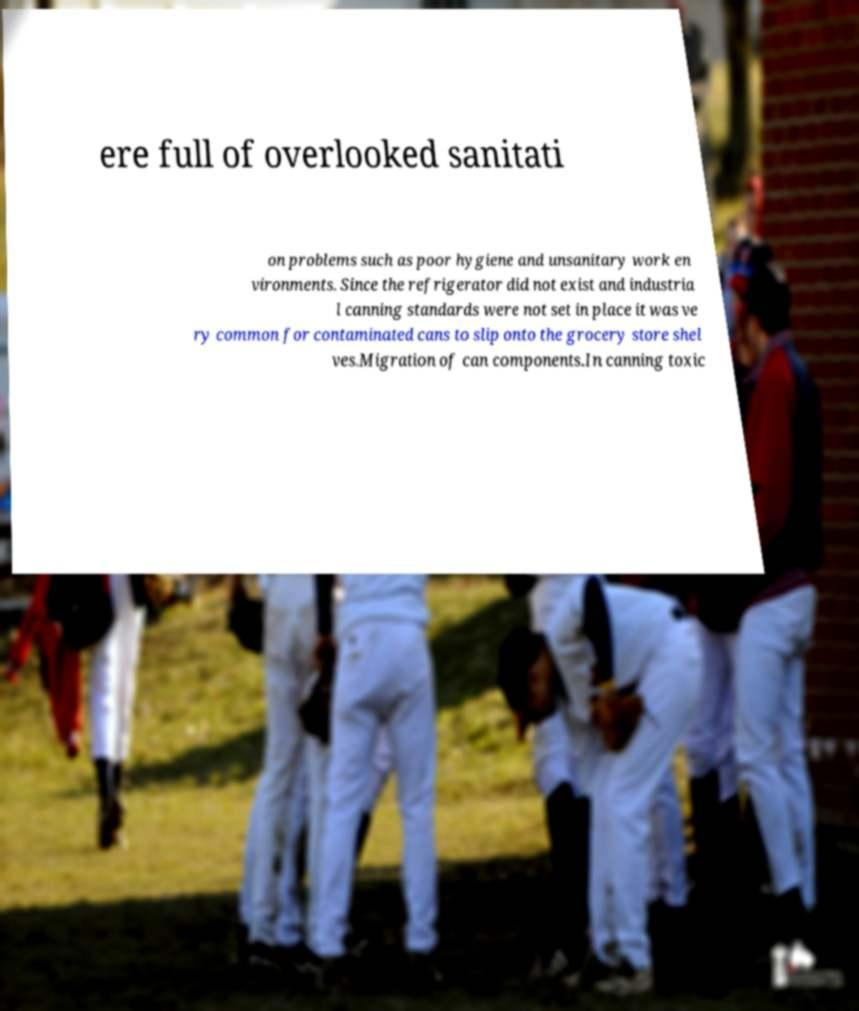Can you accurately transcribe the text from the provided image for me? ere full of overlooked sanitati on problems such as poor hygiene and unsanitary work en vironments. Since the refrigerator did not exist and industria l canning standards were not set in place it was ve ry common for contaminated cans to slip onto the grocery store shel ves.Migration of can components.In canning toxic 